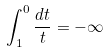Convert formula to latex. <formula><loc_0><loc_0><loc_500><loc_500>\int _ { 1 } ^ { 0 } \frac { d t } { t } = - \infty</formula> 